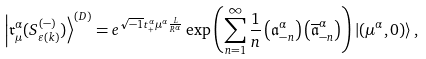<formula> <loc_0><loc_0><loc_500><loc_500>\left | \mathfrak { r } _ { \mu } ^ { \alpha } ( S _ { \varepsilon ( k ) } ^ { ( - ) } ) \right \rangle ^ { ( D ) } = e ^ { \sqrt { - 1 } t _ { + } ^ { \alpha } \mu ^ { \alpha } \frac { L } { R ^ { \alpha } } } \exp \left ( \sum _ { n = 1 } ^ { \infty } \frac { 1 } { n } \left ( \mathfrak { a } _ { - n } ^ { \alpha } \right ) \left ( \overline { \mathfrak { a } } _ { - n } ^ { \alpha } \right ) \right ) \left | ( \mu ^ { \alpha } , 0 ) \right \rangle ,</formula> 